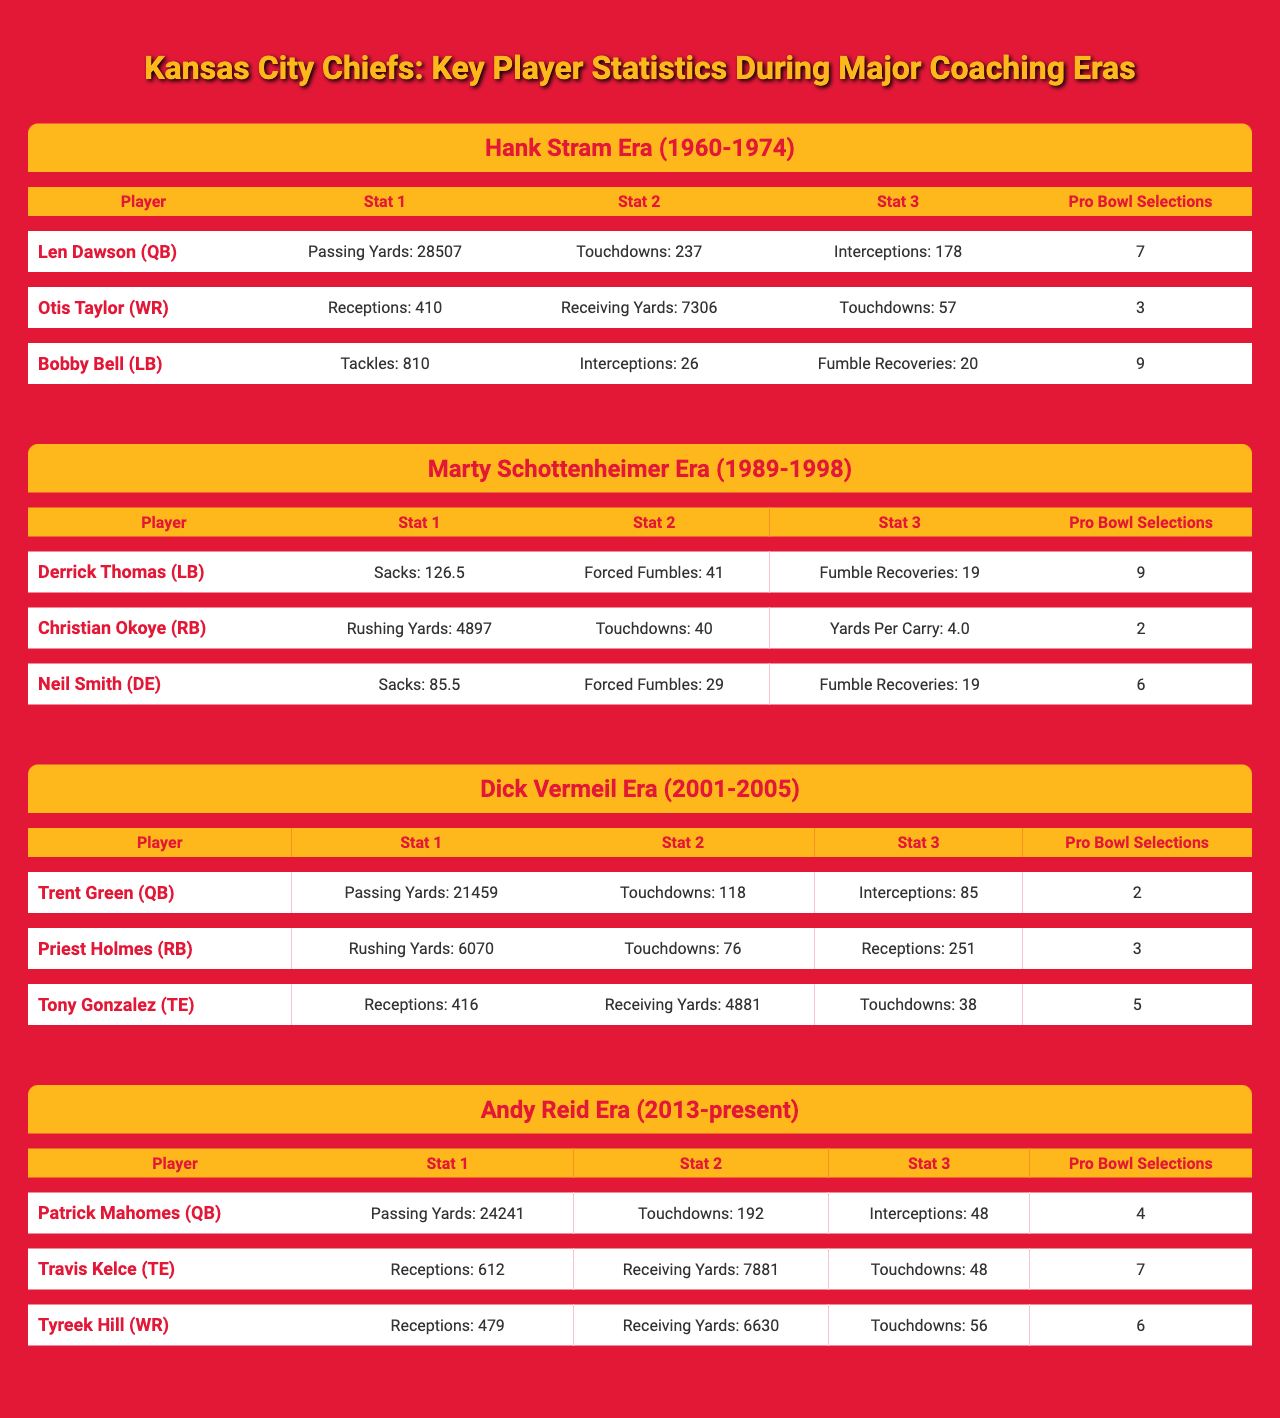What is the total number of Pro Bowl selections for players in the Hank Stram Era? The table shows that Len Dawson had 7 Pro Bowl selections, Otis Taylor had 3, and Bobby Bell had 9. Adding these together gives 7 + 3 + 9 = 19.
Answer: 19 Which player in the Andy Reid Era has the highest number of receiving yards? The table indicates that Travis Kelce has 7881 receiving yards, while Tyreek Hill has 6630. Since 7881 > 6630, Travis Kelce has the highest number of receiving yards.
Answer: Travis Kelce How many touchdowns did Priest Holmes score compared to Christian Okoye? The table shows Priest Holmes scored 76 touchdowns and Christian Okoye scored 40. The difference is 76 - 40 = 36.
Answer: 36 Which coaching era had the player with the most sacks? Derrick Thomas from the Marty Schottenheimer Era had 126.5 sacks, which is higher than any other player’s stats listed in the table. This can be confirmed by comparing all sack totals presented.
Answer: Marty Schottenheimer Era Is it true that Trent Green had more Pro Bowl selections than Priest Holmes? The table states that Trent Green had 2 Pro Bowl selections and Priest Holmes had 3. Since 2 is less than 3, it’s false that Trent Green had more Pro Bowl selections.
Answer: False What is the average number of touchdowns scored by the players in the Dick Vermeil Era? Trent Green scored 118 touchdowns, Priest Holmes 76, and Tony Gonzalez 38. The total is 118 + 76 + 38 = 232. Dividing by the number of players (3) gives 232 / 3 = 77.33, which can be rounded down to 77.
Answer: 77 Who had more career interceptions, Len Dawson or Trent Green? The table shows Len Dawson had 178 interceptions and Trent Green had 85. Since 178 > 85, Len Dawson had more interceptions.
Answer: Len Dawson What is the difference in Pro Bowl selections between Derrick Thomas and Neil Smith? Derrick Thomas had 9 Pro Bowl selections and Neil Smith had 6. The difference is 9 - 6 = 3.
Answer: 3 How many total rushing yards did players from the Marty Schottenheimer Era accumulate? Christian Okoye had 4897 rushing yards. Since he is the only rushing player listed in that era, the total is just 4897.
Answer: 4897 Which player from the Hank Stram Era had the most fumble recoveries? Bobby Bell had 20 fumble recoveries, while Len Dawson and Otis Taylor are not credited with fumble recoveries. Therefore, Bobby Bell had the most in that era.
Answer: Bobby Bell If you combine the passing touchdowns for Trent Green and Patrick Mahomes, what would be the total? Trent Green had 118 passing touchdowns and Patrick Mahomes had 192. The total is 118 + 192 = 310.
Answer: 310 